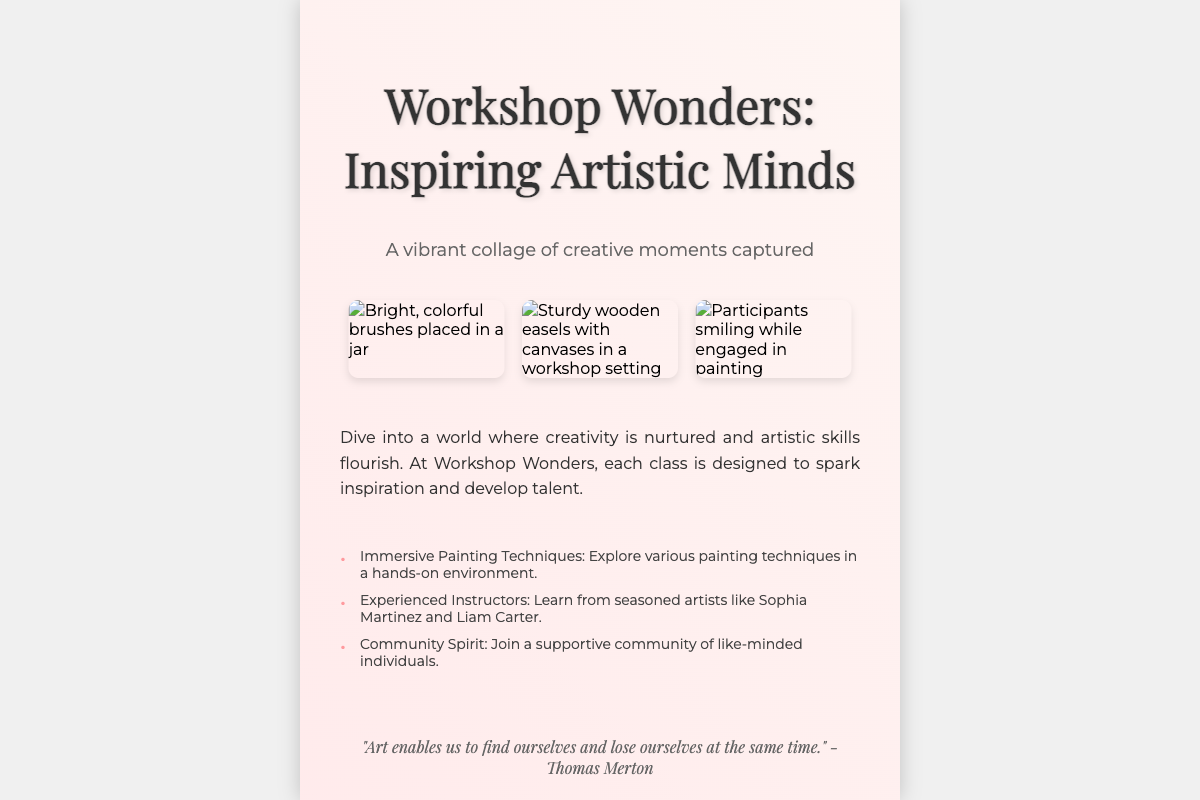What is the title of the book? The title of the book is prominently displayed at the top of the cover.
Answer: Workshop Wonders: Inspiring Artistic Minds Who are two of the experienced instructors mentioned? The document lists Sophia Martinez and Liam Carter as experienced instructors.
Answer: Sophia Martinez and Liam Carter What is the main theme of the book cover? The book cover focuses on creativity and artistic expression, highlighted through visuals and text.
Answer: Creativity and artistic expression What type of techniques will participants explore in the workshops? The document mentions that participants will explore various painting techniques.
Answer: Painting techniques How many images are displayed on the cover? The cover features three images showcasing different aspects of the workshop.
Answer: Three images What does the subtitle of the book suggest about its content? The subtitle indicates that the book captures vibrant creative moments, suggesting a visual and experiential focus.
Answer: Creative moments captured What quote is included in the document? A notable quote by Thomas Merton is included to inspire readers, highlighting the essence of art.
Answer: "Art enables us to find ourselves and lose ourselves at the same time." How does the document encourage participation? The footer provides a call-to-action inviting readers to join the next workshop.
Answer: Join our next workshop and unleash your inner artist! 